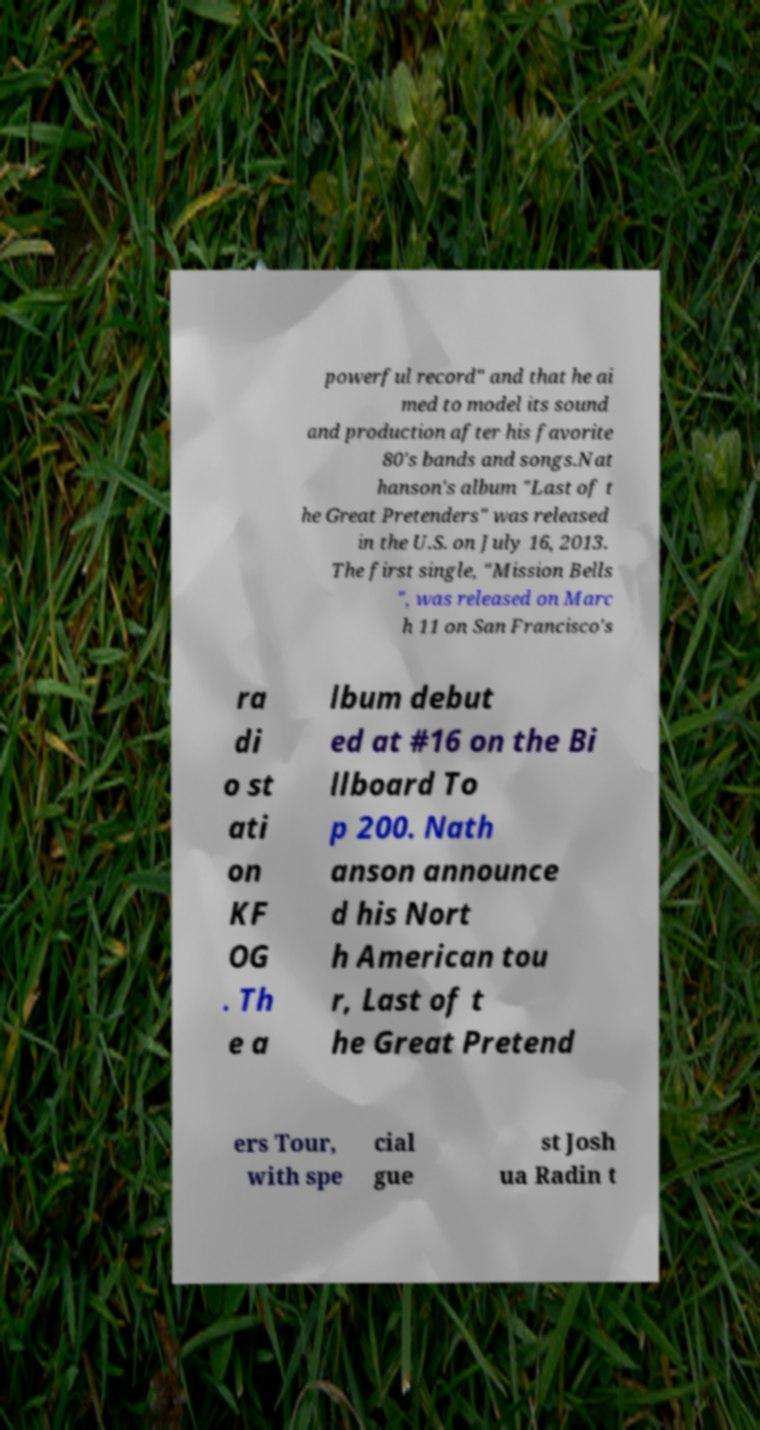Could you assist in decoding the text presented in this image and type it out clearly? powerful record" and that he ai med to model its sound and production after his favorite 80's bands and songs.Nat hanson's album "Last of t he Great Pretenders" was released in the U.S. on July 16, 2013. The first single, "Mission Bells ", was released on Marc h 11 on San Francisco's ra di o st ati on KF OG . Th e a lbum debut ed at #16 on the Bi llboard To p 200. Nath anson announce d his Nort h American tou r, Last of t he Great Pretend ers Tour, with spe cial gue st Josh ua Radin t 